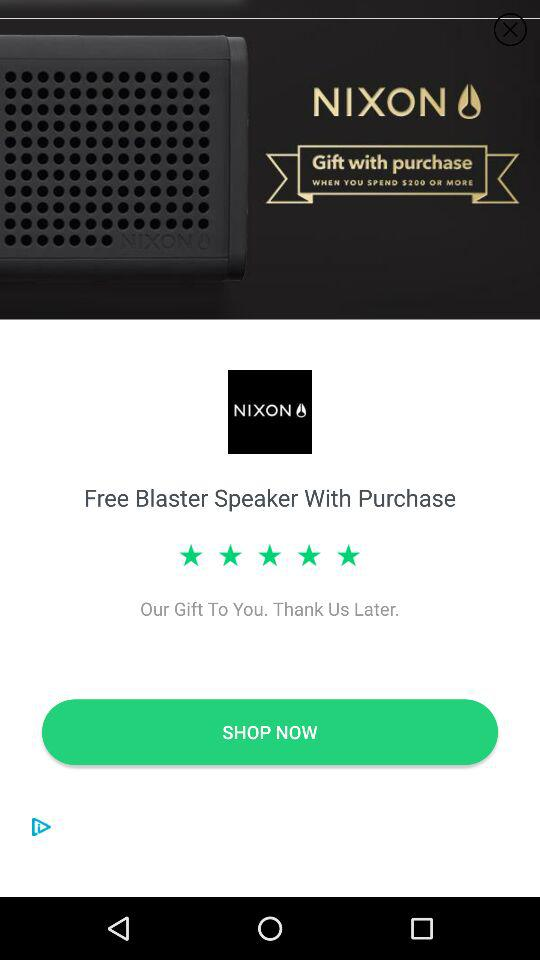What is the name of the application? The name of the application is "NIXON". 